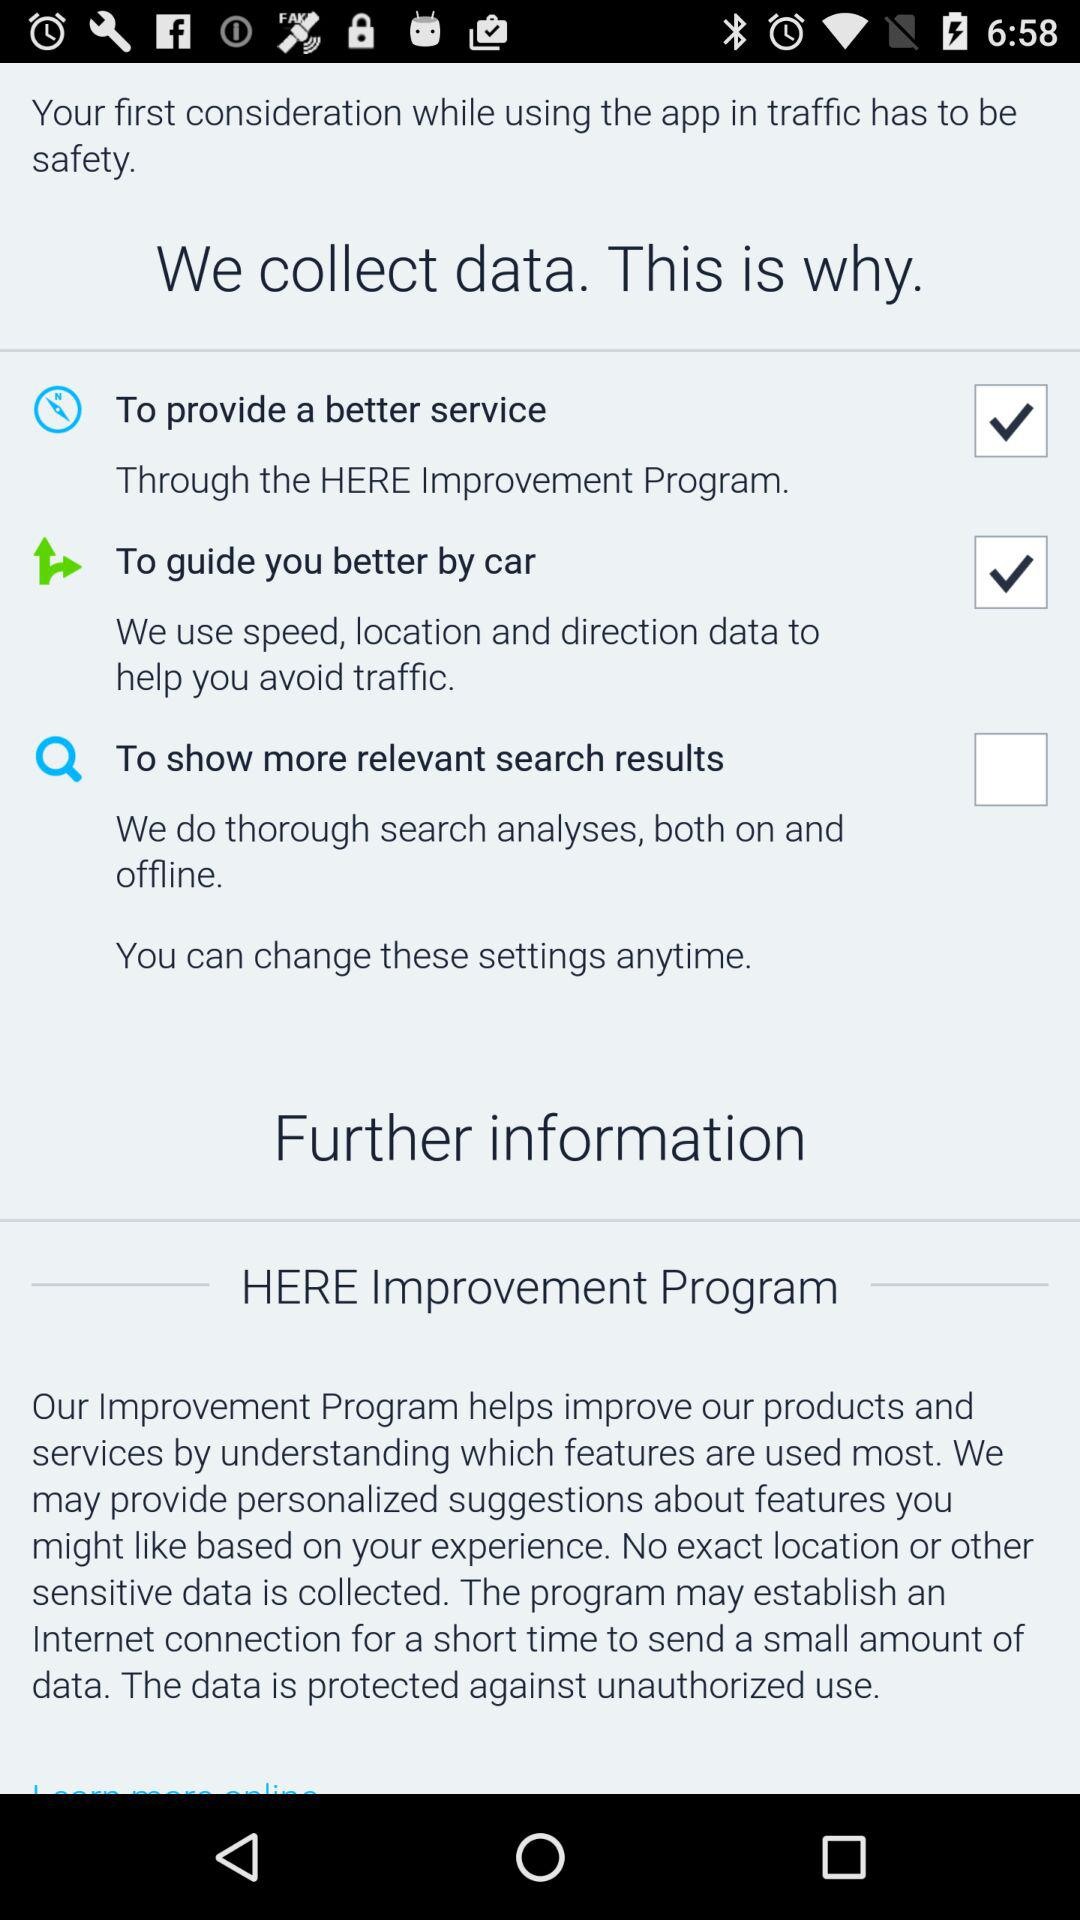What is the status of "To show more relevant search results"? The status is "off". 